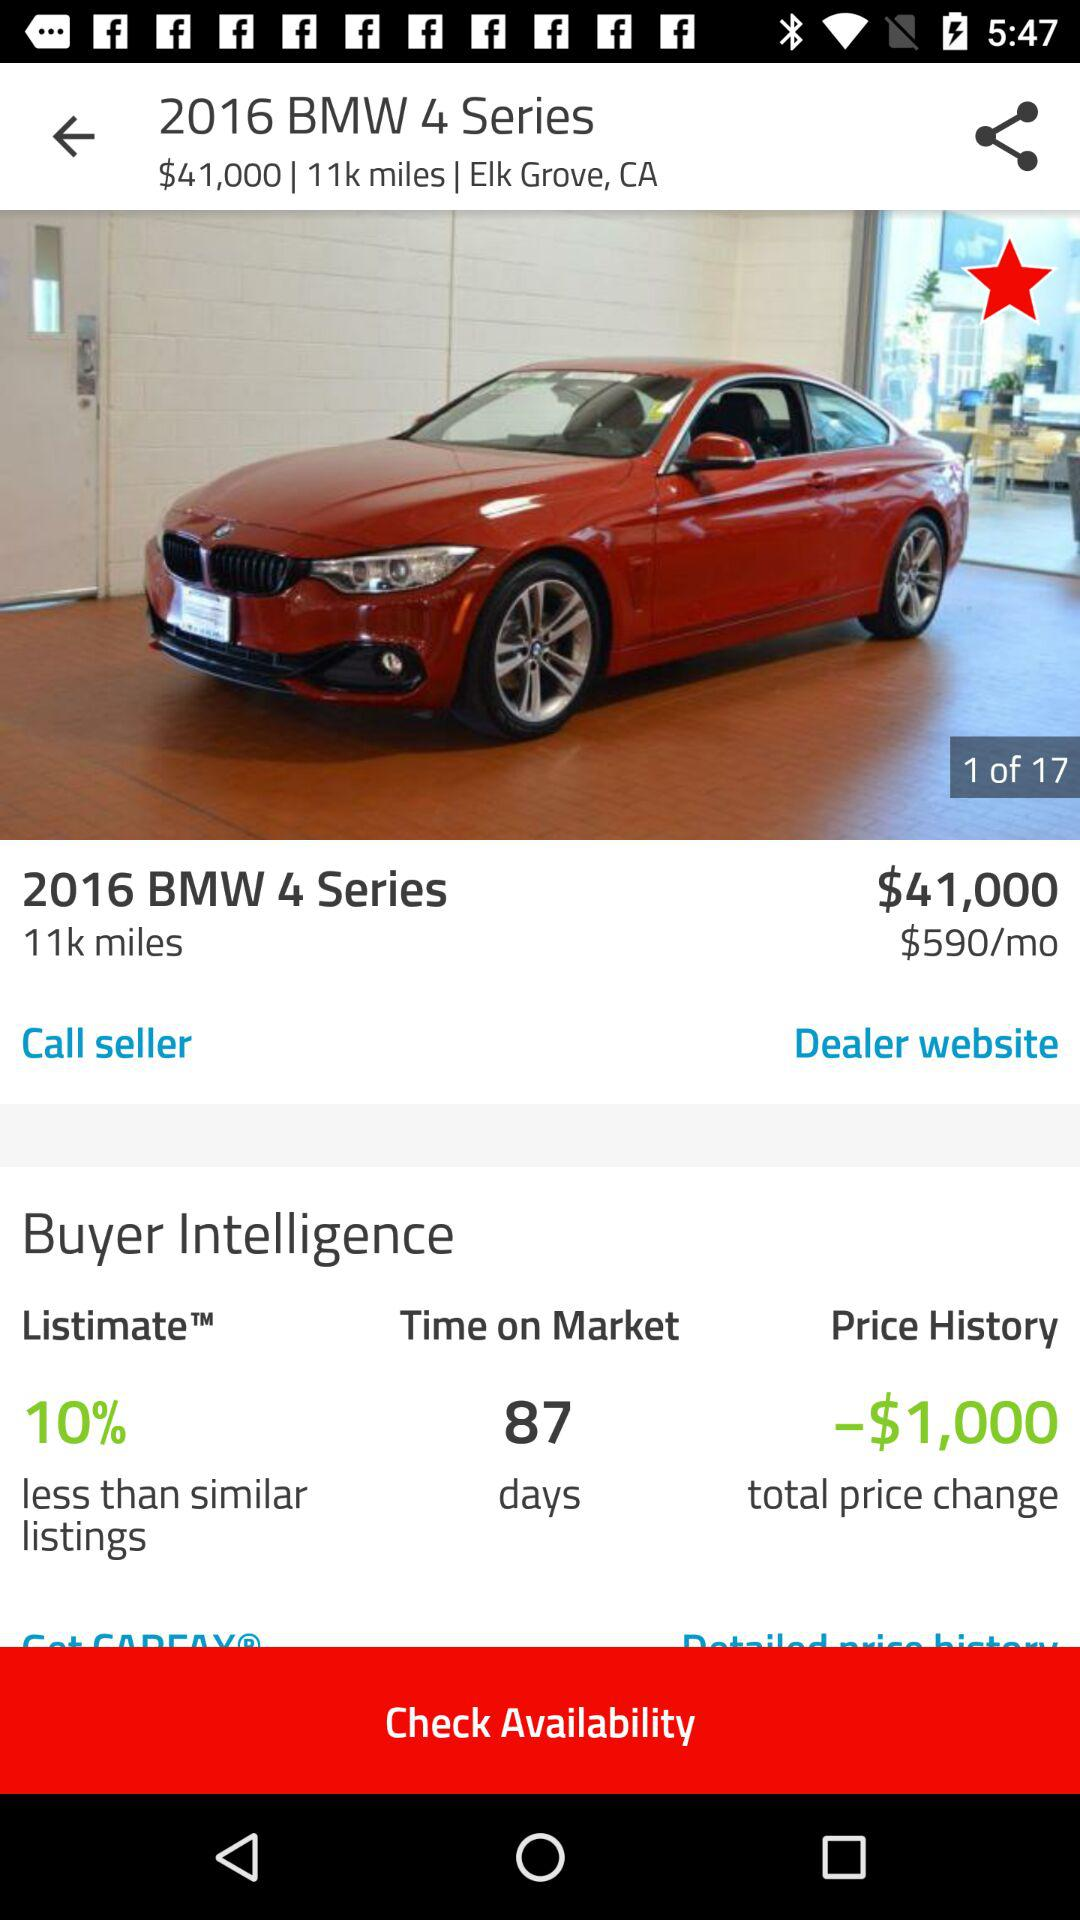How many photos in total are there? There are 17 photos. 